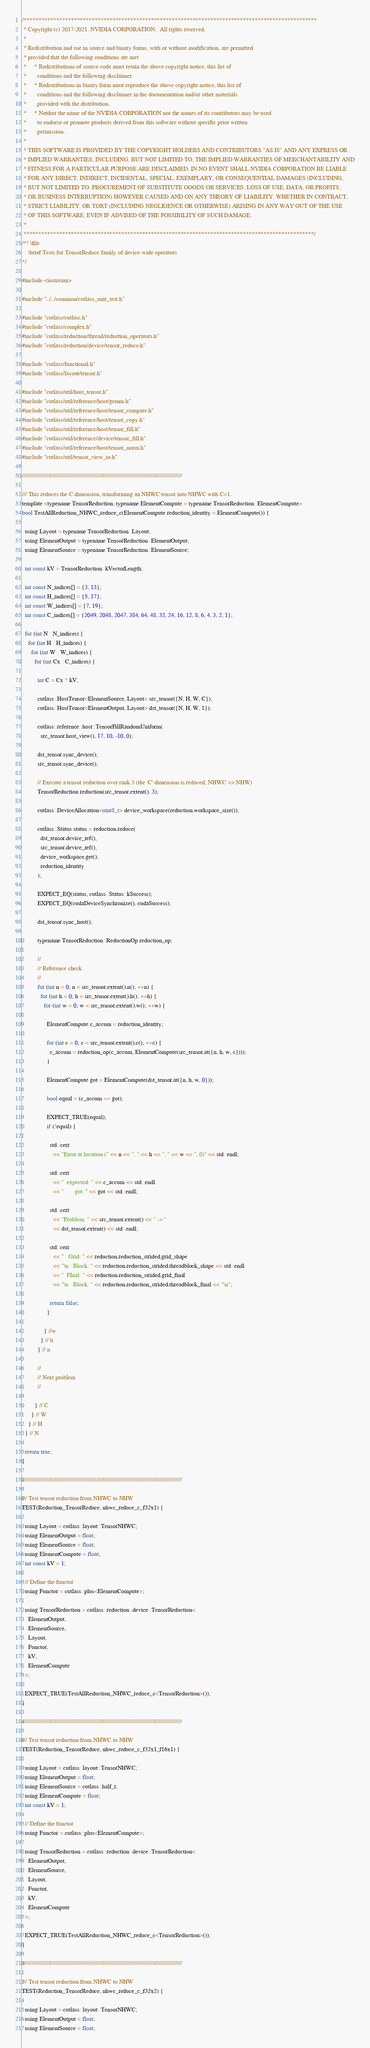Convert code to text. <code><loc_0><loc_0><loc_500><loc_500><_Cuda_>/***************************************************************************************************
 * Copyright (c) 2017-2021, NVIDIA CORPORATION.  All rights reserved.
 *
 * Redistribution and use in source and binary forms, with or without modification, are permitted
 * provided that the following conditions are met:
 *     * Redistributions of source code must retain the above copyright notice, this list of
 *       conditions and the following disclaimer.
 *     * Redistributions in binary form must reproduce the above copyright notice, this list of
 *       conditions and the following disclaimer in the documentation and/or other materials
 *       provided with the distribution.
 *     * Neither the name of the NVIDIA CORPORATION nor the names of its contributors may be used
 *       to endorse or promote products derived from this software without specific prior written
 *       permission.
 *
 * THIS SOFTWARE IS PROVIDED BY THE COPYRIGHT HOLDERS AND CONTRIBUTORS "AS IS" AND ANY EXPRESS OR
 * IMPLIED WARRANTIES, INCLUDING, BUT NOT LIMITED TO, THE IMPLIED WARRANTIES OF MERCHANTABILITY AND
 * FITNESS FOR A PARTICULAR PURPOSE ARE DISCLAIMED. IN NO EVENT SHALL NVIDIA CORPORATION BE LIABLE
 * FOR ANY DIRECT, INDIRECT, INCIDENTAL, SPECIAL, EXEMPLARY, OR CONSEQUENTIAL DAMAGES (INCLUDING,
 * BUT NOT LIMITED TO, PROCUREMENT OF SUBSTITUTE GOODS OR SERVICES; LOSS OF USE, DATA, OR PROFITS;
 * OR BUSINESS INTERRUPTION) HOWEVER CAUSED AND ON ANY THEORY OF LIABILITY, WHETHER IN CONTRACT,
 * STRICT LIABILITY, OR TORT (INCLUDING NEGLIGENCE OR OTHERWISE) ARISING IN ANY WAY OUT OF THE USE
 * OF THIS SOFTWARE, EVEN IF ADVISED OF THE POSSIBILITY OF SUCH DAMAGE.
 *
 **************************************************************************************************/
/*! \file
    \brief Tests for TensorReduce family of device-wide operators
*/

#include <iostream>

#include "../../common/cutlass_unit_test.h"

#include "cutlass/cutlass.h"
#include "cutlass/complex.h"
#include "cutlass/reduction/thread/reduction_operators.h"
#include "cutlass/reduction/device/tensor_reduce.h"

#include "cutlass/functional.h"
#include "cutlass/layout/tensor.h"

#include "cutlass/util/host_tensor.h"
#include "cutlass/util/reference/host/gemm.h"
#include "cutlass/util/reference/host/tensor_compare.h"
#include "cutlass/util/reference/host/tensor_copy.h"
#include "cutlass/util/reference/host/tensor_fill.h"
#include "cutlass/util/reference/device/tensor_fill.h"
#include "cutlass/util/reference/host/tensor_norm.h"
#include "cutlass/util/tensor_view_io.h"

/////////////////////////////////////////////////////////////////////////////////////////////////

/// This reduces the C dimension, transforming an NHWC tensor into NHWC with C=1.
template <typename TensorReduction, typename ElementCompute = typename TensorReduction::ElementCompute>
bool TestAllReduction_NHWC_reduce_c(ElementCompute reduction_identity = ElementCompute()) {

  using Layout = typename TensorReduction::Layout;
  using ElementOutput = typename TensorReduction::ElementOutput;
  using ElementSource = typename TensorReduction::ElementSource;

  int const kV = TensorReduction::kVectorLength;

  int const N_indices[] = {3, 13};
  int const H_indices[] = {5, 17};
  int const W_indices[] = {7, 19};
  int const C_indices[] = {2049, 2048, 2047, 384, 64, 48, 32, 24, 16, 12, 8, 6, 4, 3, 2, 1};
  
  for (int N : N_indices) {
    for (int H : H_indices) {
      for (int W : W_indices) {
        for (int Cx : C_indices) {

          int C = Cx * kV;

          cutlass::HostTensor<ElementSource, Layout> src_tensor({N, H, W, C});
          cutlass::HostTensor<ElementOutput, Layout> dst_tensor({N, H, W, 1});

          cutlass::reference::host::TensorFillRandomUniform(
            src_tensor.host_view(), 17, 10, -10, 0);

          dst_tensor.sync_device();
          src_tensor.sync_device();

          // Execute a tensor reduction over rank 3 (the 'C' dimension is reduced; NHWC => NHW)
          TensorReduction reduction(src_tensor.extent(), 3);

          cutlass::DeviceAllocation<uint8_t> device_workspace(reduction.workspace_size());

          cutlass::Status status = reduction.reduce(
            dst_tensor.device_ref(),
            src_tensor.device_ref(),
            device_workspace.get(),
            reduction_identity
          );

          EXPECT_EQ(status, cutlass::Status::kSuccess);
          EXPECT_EQ(cudaDeviceSynchronize(), cudaSuccess);
          
          dst_tensor.sync_host();

          typename TensorReduction::ReductionOp reduction_op;

          //
          // Reference check
          //
          for (int n = 0; n < src_tensor.extent().n(); ++n) {
            for (int h = 0; h < src_tensor.extent().h(); ++h) {
              for (int w = 0; w < src_tensor.extent().w(); ++w) {

                ElementCompute c_accum = reduction_identity;

                for (int c = 0; c < src_tensor.extent().c(); ++c) {
                  c_accum = reduction_op(c_accum, ElementCompute(src_tensor.at({n, h, w, c})));
                }

                ElementCompute got = ElementCompute(dst_tensor.at({n, h, w, 0}));

                bool equal = (c_accum == got);

                EXPECT_TRUE(equal);
                if (!equal) {

                  std::cerr 
                    << "Error at location (" << n << ", " << h << ", " << w << ", 0)" << std::endl;

                  std::cerr 
                    << "  expected: " << c_accum << std::endl
                    << "       got: " << got << std::endl;

                  std::cerr 
                    << "Problem: " << src_tensor.extent() << " -> " 
                    << dst_tensor.extent() << std::endl;

                  std::cerr 
                    << "   Grid: " << reduction.reduction_strided.grid_shape 
                    << "\n   Block: " << reduction.reduction_strided.threadblock_shape << std::endl
                    << "  FInal: " << reduction.reduction_strided.grid_final 
                    << "\n   Block: " << reduction.reduction_strided.threadblock_final << "\n";

                  return false;
                }

              } //w
            } // h
          } // n
          
          //
          // Next problem
          //

        } // C
      } // W
    } // H
  } // N

  return true;
}

/////////////////////////////////////////////////////////////////////////////////////////////////

/// Test tensor reduction from NHWC to NHW
TEST(Reduction_TensorReduce, nhwc_reduce_c_f32x1) {

  using Layout = cutlass::layout::TensorNHWC;
  using ElementOutput = float;
  using ElementSource = float;
  using ElementCompute = float;
  int const kV = 1;
  
  // Define the functor
  using Functor = cutlass::plus<ElementCompute>;

  using TensorReduction = cutlass::reduction::device::TensorReduction<
    ElementOutput,
    ElementSource,
    Layout,
    Functor,
    kV,
    ElementCompute
  >;
  
  EXPECT_TRUE(TestAllReduction_NHWC_reduce_c<TensorReduction>());
}

/////////////////////////////////////////////////////////////////////////////////////////////////

/// Test tensor reduction from NHWC to NHW
TEST(Reduction_TensorReduce, nhwc_reduce_c_f32x1_f16x1) {

  using Layout = cutlass::layout::TensorNHWC;
  using ElementOutput = float;
  using ElementSource = cutlass::half_t;
  using ElementCompute = float;
  int const kV = 1;
  
  // Define the functor
  using Functor = cutlass::plus<ElementCompute>;

  using TensorReduction = cutlass::reduction::device::TensorReduction<
    ElementOutput,
    ElementSource,
    Layout,
    Functor,
    kV,
    ElementCompute
  >;
  
  EXPECT_TRUE(TestAllReduction_NHWC_reduce_c<TensorReduction>());
}

/////////////////////////////////////////////////////////////////////////////////////////////////

/// Test tensor reduction from NHWC to NHW
TEST(Reduction_TensorReduce, nhwc_reduce_c_f32x2) {

  using Layout = cutlass::layout::TensorNHWC;
  using ElementOutput = float;
  using ElementSource = float;</code> 